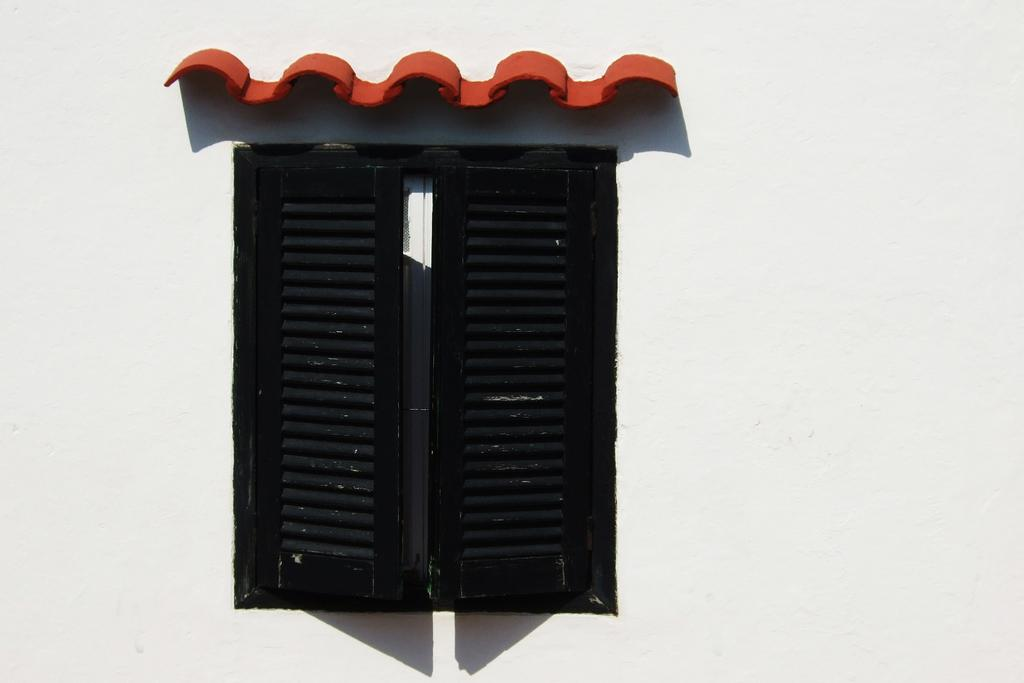What can be seen in the image that provides a view of the outdoors? There is a window in the image that provides a view of the outdoors. Where is the window located in the image? The window is on a wall in the image. What type of furniture is visible in the image? There is no furniture visible in the image; it only features a window on a wall. 